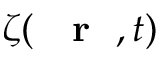<formula> <loc_0><loc_0><loc_500><loc_500>\zeta ( { r } , t )</formula> 